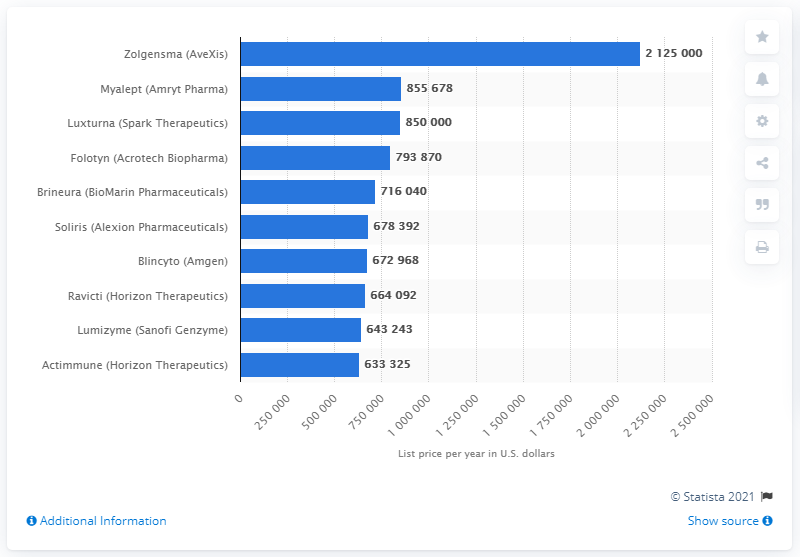Highlight a few significant elements in this photo. The list price for Zolgensma per year was 212,50000. 